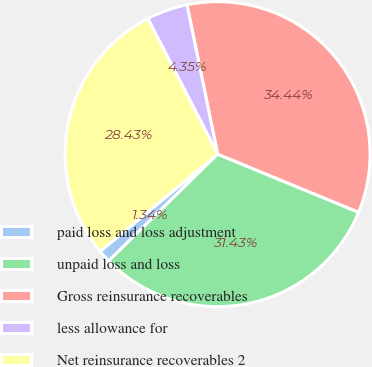Convert chart. <chart><loc_0><loc_0><loc_500><loc_500><pie_chart><fcel>paid loss and loss adjustment<fcel>unpaid loss and loss<fcel>Gross reinsurance recoverables<fcel>less allowance for<fcel>Net reinsurance recoverables 2<nl><fcel>1.34%<fcel>31.43%<fcel>34.44%<fcel>4.35%<fcel>28.43%<nl></chart> 